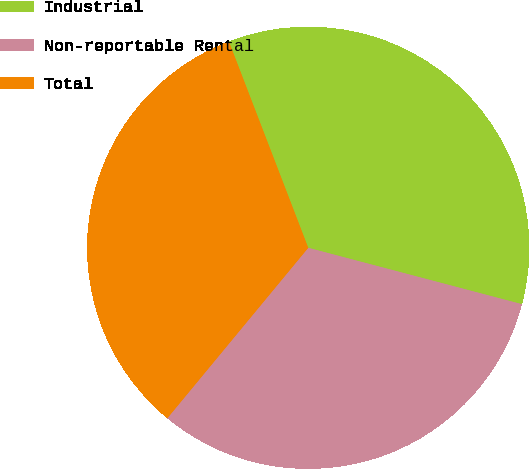<chart> <loc_0><loc_0><loc_500><loc_500><pie_chart><fcel>Industrial<fcel>Non-reportable Rental<fcel>Total<nl><fcel>34.95%<fcel>31.89%<fcel>33.16%<nl></chart> 